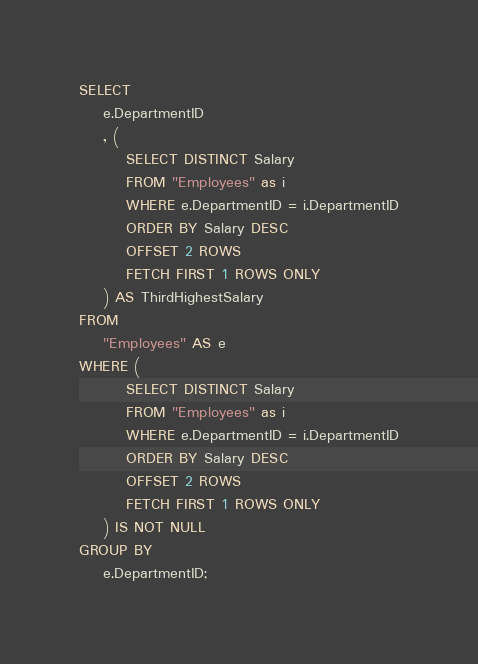<code> <loc_0><loc_0><loc_500><loc_500><_SQL_>SELECT
	e.DepartmentID
	, (
		SELECT DISTINCT Salary 
		FROM "Employees" as i
		WHERE e.DepartmentID = i.DepartmentID
		ORDER BY Salary DESC
		OFFSET 2 ROWS
		FETCH FIRST 1 ROWS ONLY 
	) AS ThirdHighestSalary
FROM
	"Employees" AS e
WHERE (
		SELECT DISTINCT Salary 
		FROM "Employees" as i
		WHERE e.DepartmentID = i.DepartmentID
		ORDER BY Salary DESC
		OFFSET 2 ROWS
		FETCH FIRST 1 ROWS ONLY 
	) IS NOT NULL
GROUP BY 
	e.DepartmentID;
</code> 